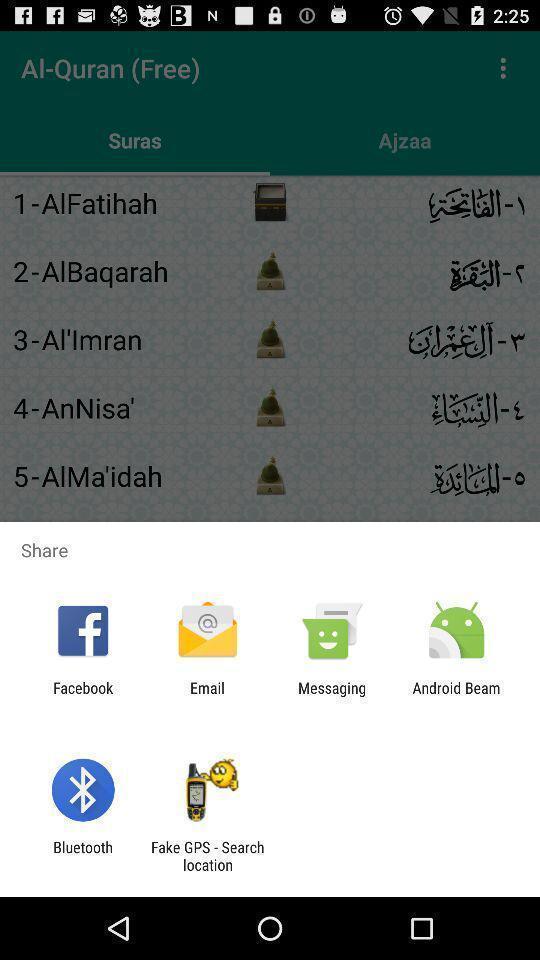Describe this image in words. Screen displaying sharing options using different social applications. 